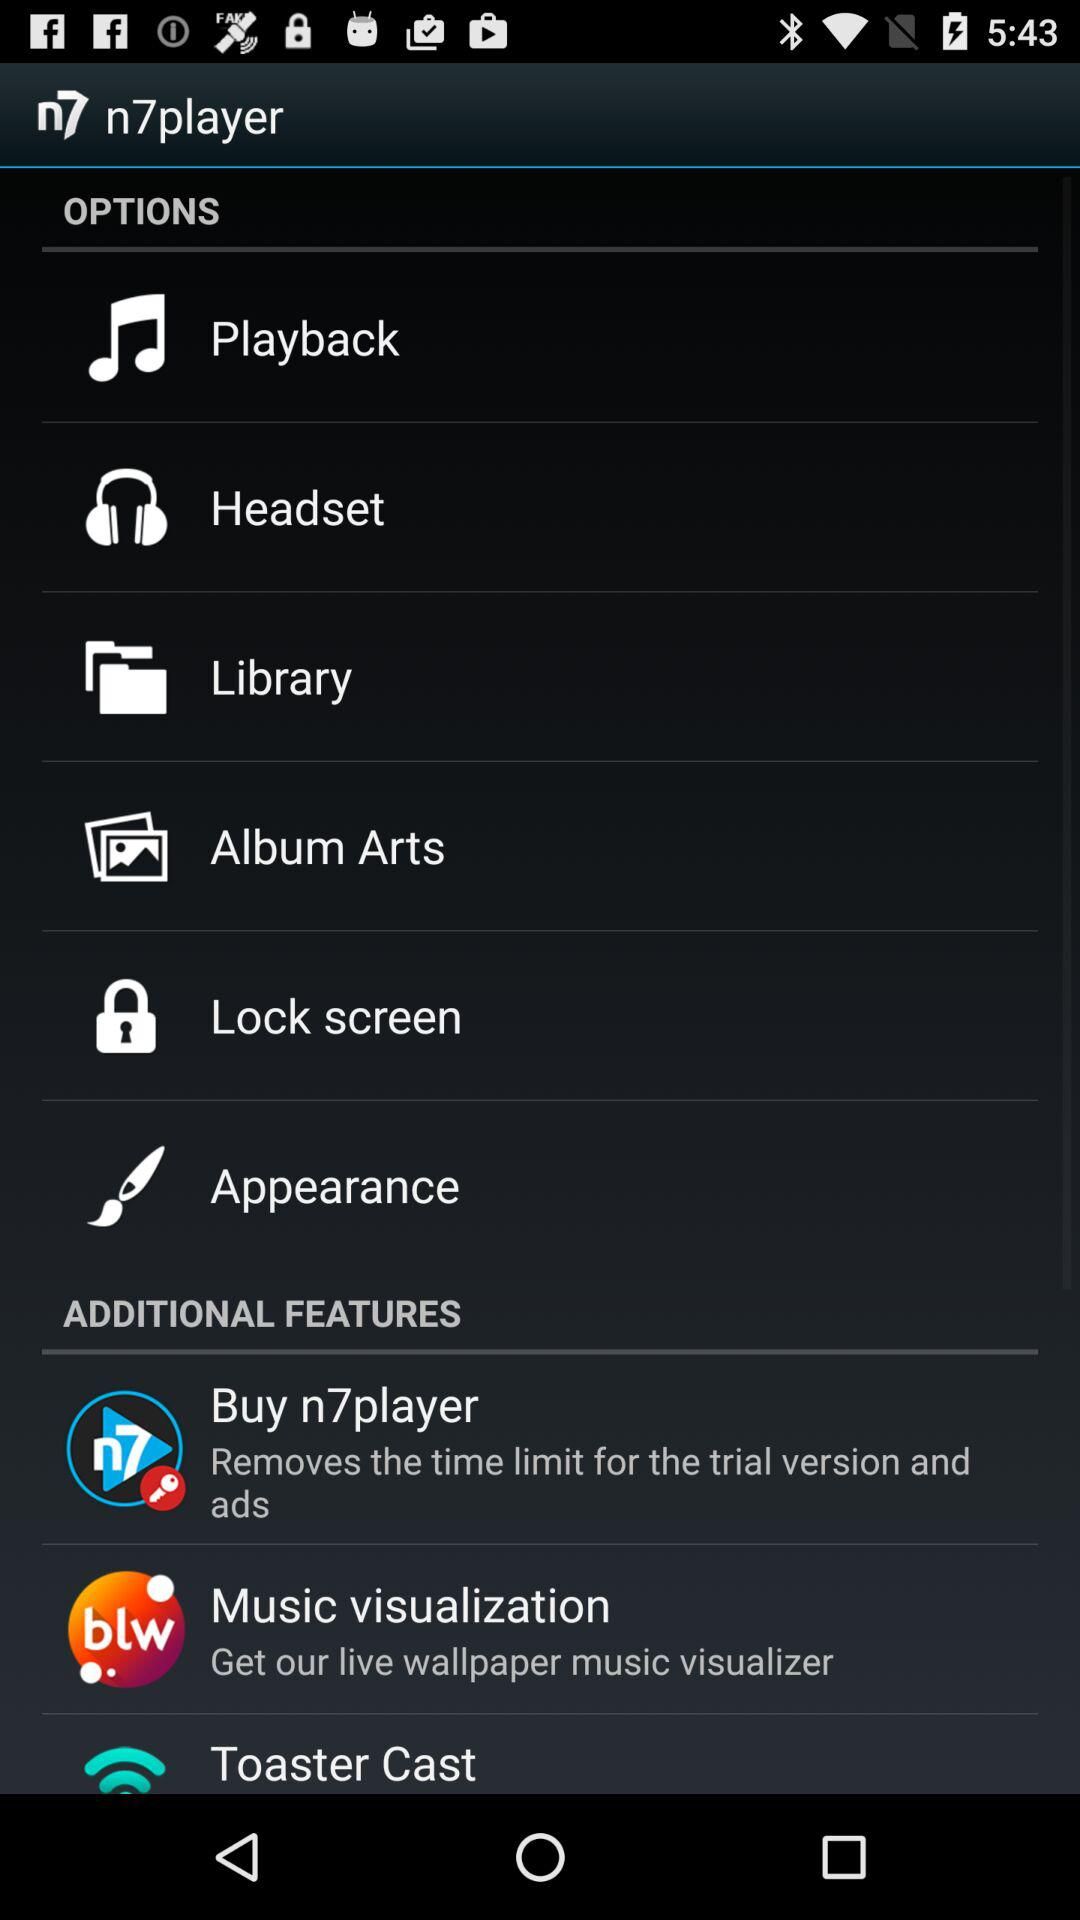How many items are in the Additional Features section?
Answer the question using a single word or phrase. 3 